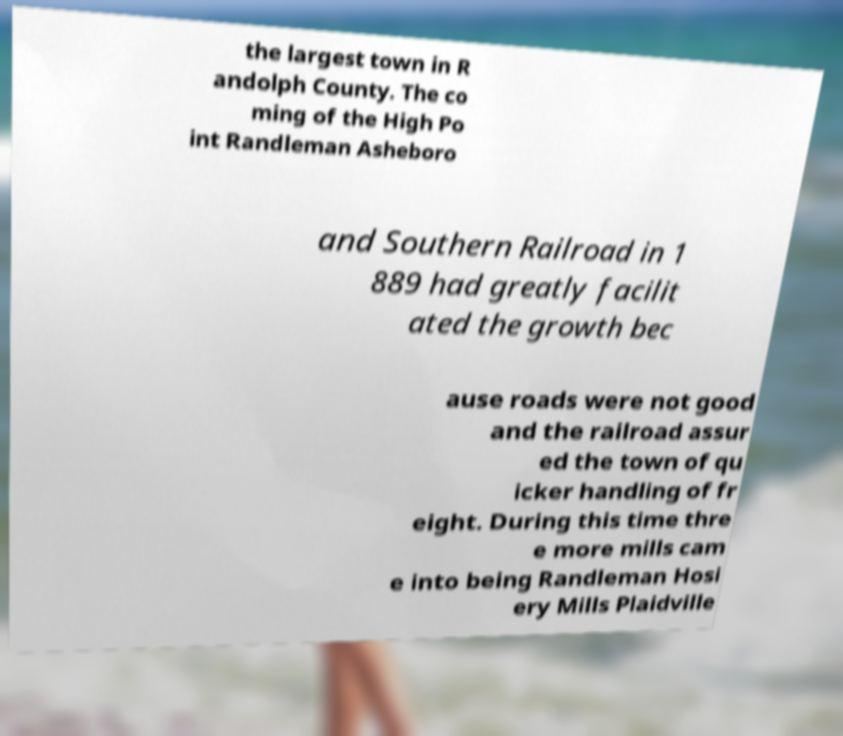There's text embedded in this image that I need extracted. Can you transcribe it verbatim? the largest town in R andolph County. The co ming of the High Po int Randleman Asheboro and Southern Railroad in 1 889 had greatly facilit ated the growth bec ause roads were not good and the railroad assur ed the town of qu icker handling of fr eight. During this time thre e more mills cam e into being Randleman Hosi ery Mills Plaidville 